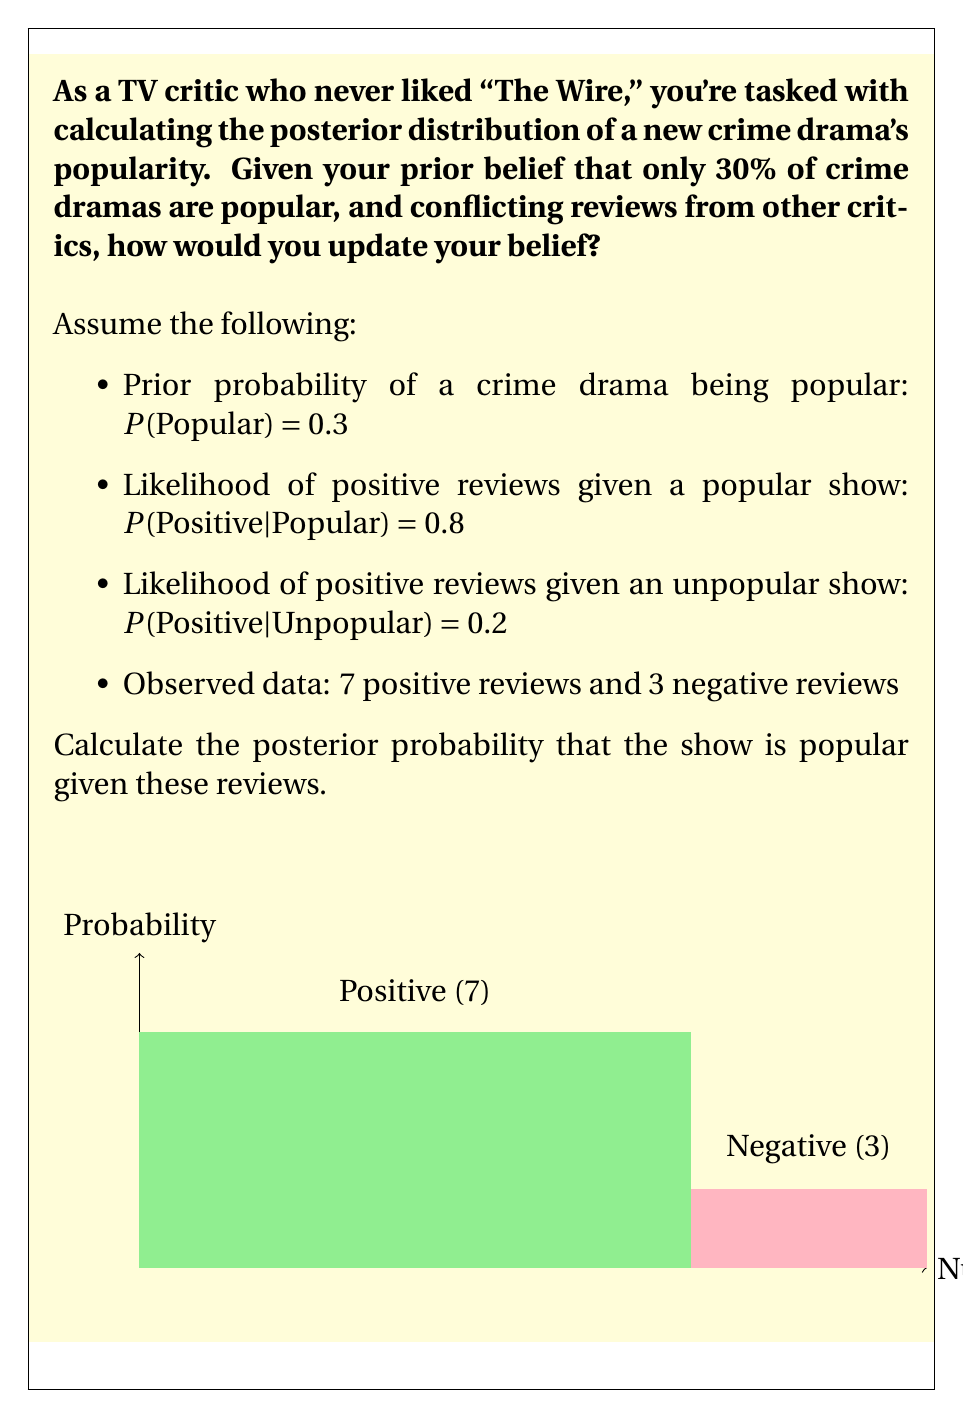Help me with this question. To solve this problem, we'll use Bayes' theorem:

$$P(Popular|Reviews) = \frac{P(Reviews|Popular) \cdot P(Popular)}{P(Reviews)}$$

1. Calculate the likelihood of the observed data:
   $$P(Reviews|Popular) = 0.8^7 \cdot 0.2^3 = 0.0001638$$
   $$P(Reviews|Unpopular) = 0.2^7 \cdot 0.8^3 = 0.0000128$$

2. Calculate the marginal likelihood:
   $$P(Reviews) = P(Reviews|Popular) \cdot P(Popular) + P(Reviews|Unpopular) \cdot P(Unpopular)$$
   $$= 0.0001638 \cdot 0.3 + 0.0000128 \cdot 0.7 = 0.00005803$$

3. Apply Bayes' theorem:
   $$P(Popular|Reviews) = \frac{0.0001638 \cdot 0.3}{0.00005803} = 0.8466$$

4. Convert to percentage:
   $$0.8466 \cdot 100\% = 84.66\%$$

Therefore, despite your initial skepticism, the posterior probability that the show is popular given these reviews is approximately 84.66%.
Answer: 84.66% 